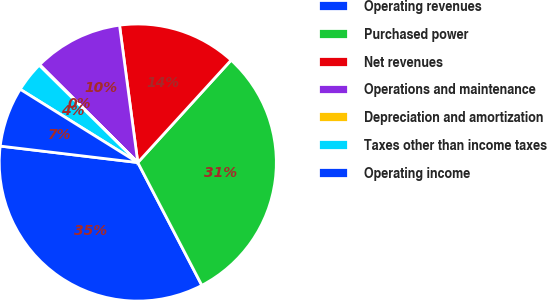Convert chart. <chart><loc_0><loc_0><loc_500><loc_500><pie_chart><fcel>Operating revenues<fcel>Purchased power<fcel>Net revenues<fcel>Operations and maintenance<fcel>Depreciation and amortization<fcel>Taxes other than income taxes<fcel>Operating income<nl><fcel>34.55%<fcel>30.59%<fcel>13.87%<fcel>10.42%<fcel>0.08%<fcel>3.53%<fcel>6.97%<nl></chart> 